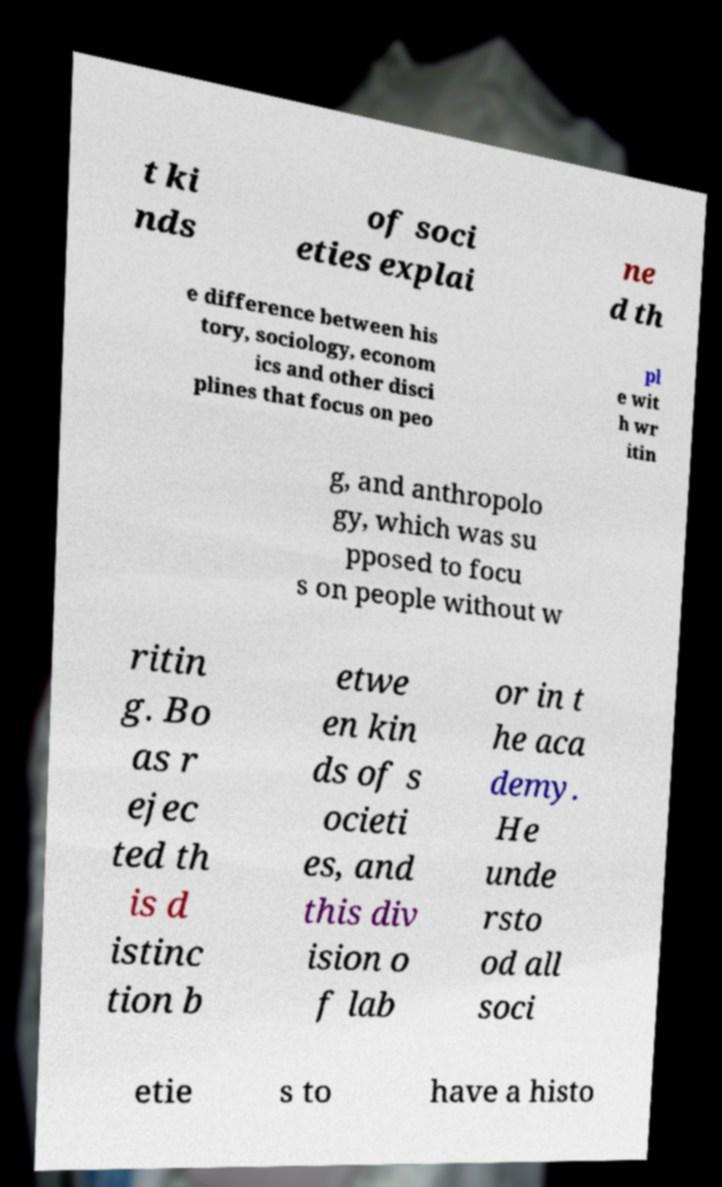Please read and relay the text visible in this image. What does it say? t ki nds of soci eties explai ne d th e difference between his tory, sociology, econom ics and other disci plines that focus on peo pl e wit h wr itin g, and anthropolo gy, which was su pposed to focu s on people without w ritin g. Bo as r ejec ted th is d istinc tion b etwe en kin ds of s ocieti es, and this div ision o f lab or in t he aca demy. He unde rsto od all soci etie s to have a histo 